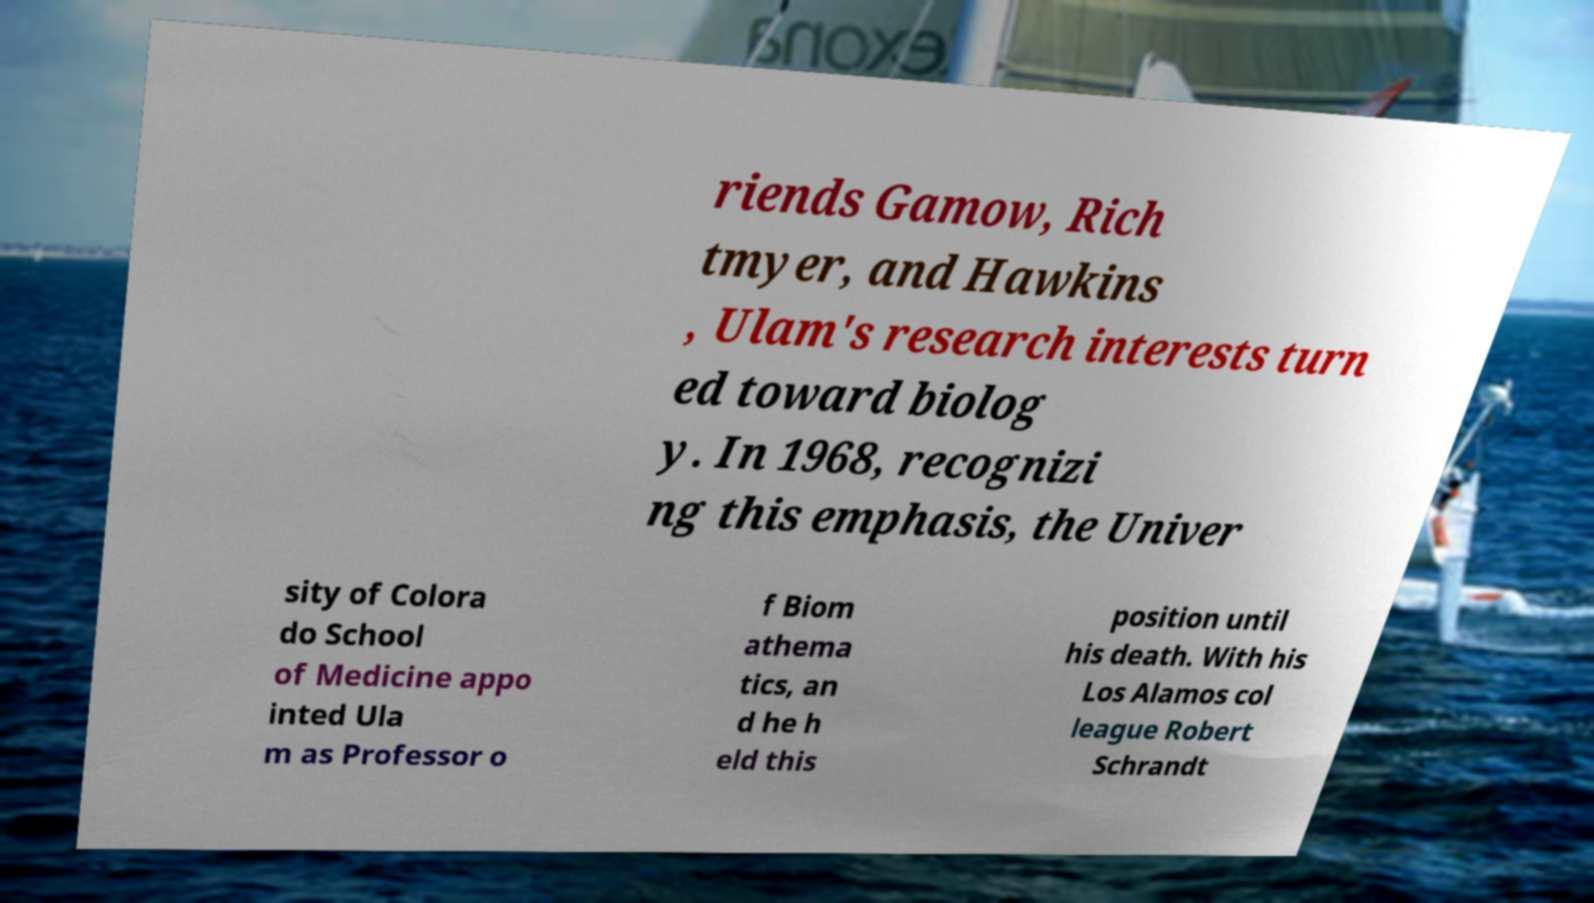What messages or text are displayed in this image? I need them in a readable, typed format. riends Gamow, Rich tmyer, and Hawkins , Ulam's research interests turn ed toward biolog y. In 1968, recognizi ng this emphasis, the Univer sity of Colora do School of Medicine appo inted Ula m as Professor o f Biom athema tics, an d he h eld this position until his death. With his Los Alamos col league Robert Schrandt 